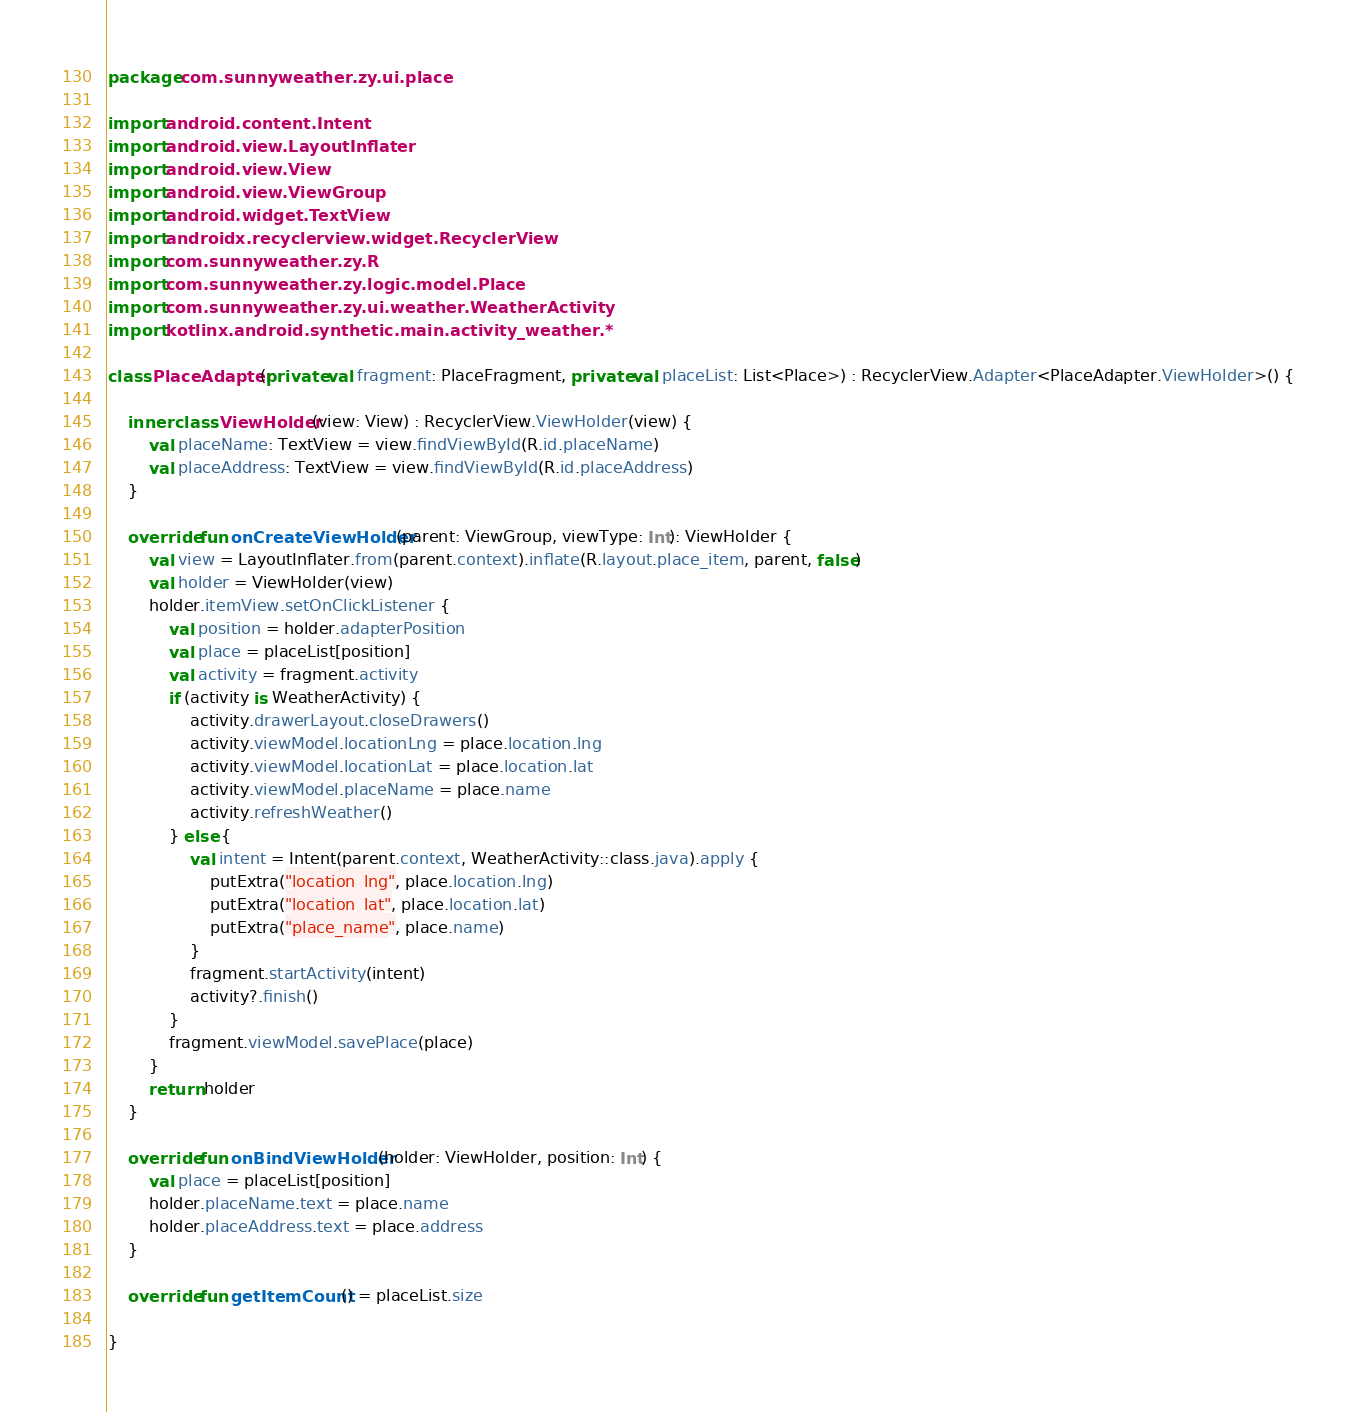Convert code to text. <code><loc_0><loc_0><loc_500><loc_500><_Kotlin_>package com.sunnyweather.zy.ui.place

import android.content.Intent
import android.view.LayoutInflater
import android.view.View
import android.view.ViewGroup
import android.widget.TextView
import androidx.recyclerview.widget.RecyclerView
import com.sunnyweather.zy.R
import com.sunnyweather.zy.logic.model.Place
import com.sunnyweather.zy.ui.weather.WeatherActivity
import kotlinx.android.synthetic.main.activity_weather.*

class PlaceAdapter(private val fragment: PlaceFragment, private val placeList: List<Place>) : RecyclerView.Adapter<PlaceAdapter.ViewHolder>() {

    inner class ViewHolder(view: View) : RecyclerView.ViewHolder(view) {
        val placeName: TextView = view.findViewById(R.id.placeName)
        val placeAddress: TextView = view.findViewById(R.id.placeAddress)
    }

    override fun onCreateViewHolder(parent: ViewGroup, viewType: Int): ViewHolder {
        val view = LayoutInflater.from(parent.context).inflate(R.layout.place_item, parent, false)
        val holder = ViewHolder(view)
        holder.itemView.setOnClickListener {
            val position = holder.adapterPosition
            val place = placeList[position]
            val activity = fragment.activity
            if (activity is WeatherActivity) {
                activity.drawerLayout.closeDrawers()
                activity.viewModel.locationLng = place.location.lng
                activity.viewModel.locationLat = place.location.lat
                activity.viewModel.placeName = place.name
                activity.refreshWeather()
            } else {
                val intent = Intent(parent.context, WeatherActivity::class.java).apply {
                    putExtra("location_lng", place.location.lng)
                    putExtra("location_lat", place.location.lat)
                    putExtra("place_name", place.name)
                }
                fragment.startActivity(intent)
                activity?.finish()
            }
            fragment.viewModel.savePlace(place)
        }
        return holder
    }

    override fun onBindViewHolder(holder: ViewHolder, position: Int) {
        val place = placeList[position]
        holder.placeName.text = place.name
        holder.placeAddress.text = place.address
    }

    override fun getItemCount() = placeList.size

}
</code> 